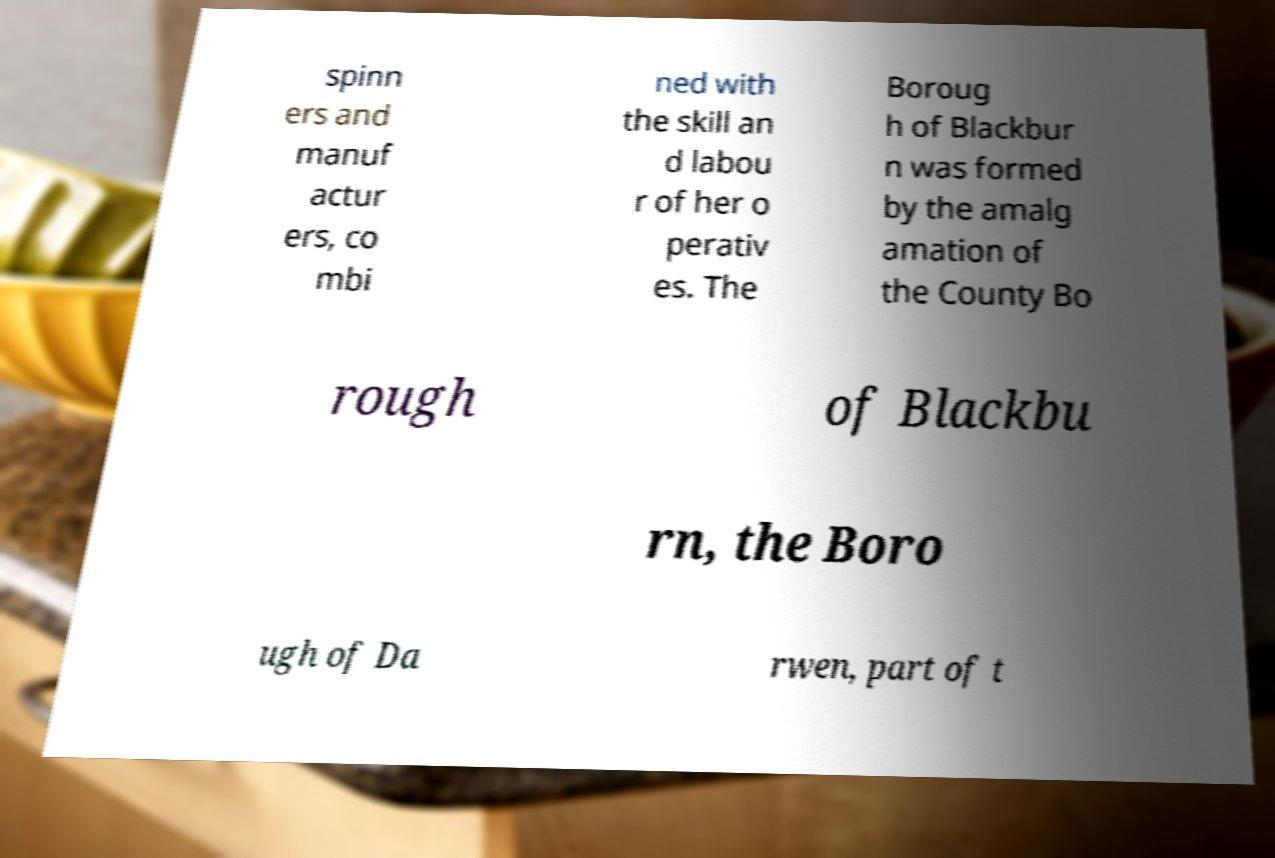What messages or text are displayed in this image? I need them in a readable, typed format. spinn ers and manuf actur ers, co mbi ned with the skill an d labou r of her o perativ es. The Boroug h of Blackbur n was formed by the amalg amation of the County Bo rough of Blackbu rn, the Boro ugh of Da rwen, part of t 